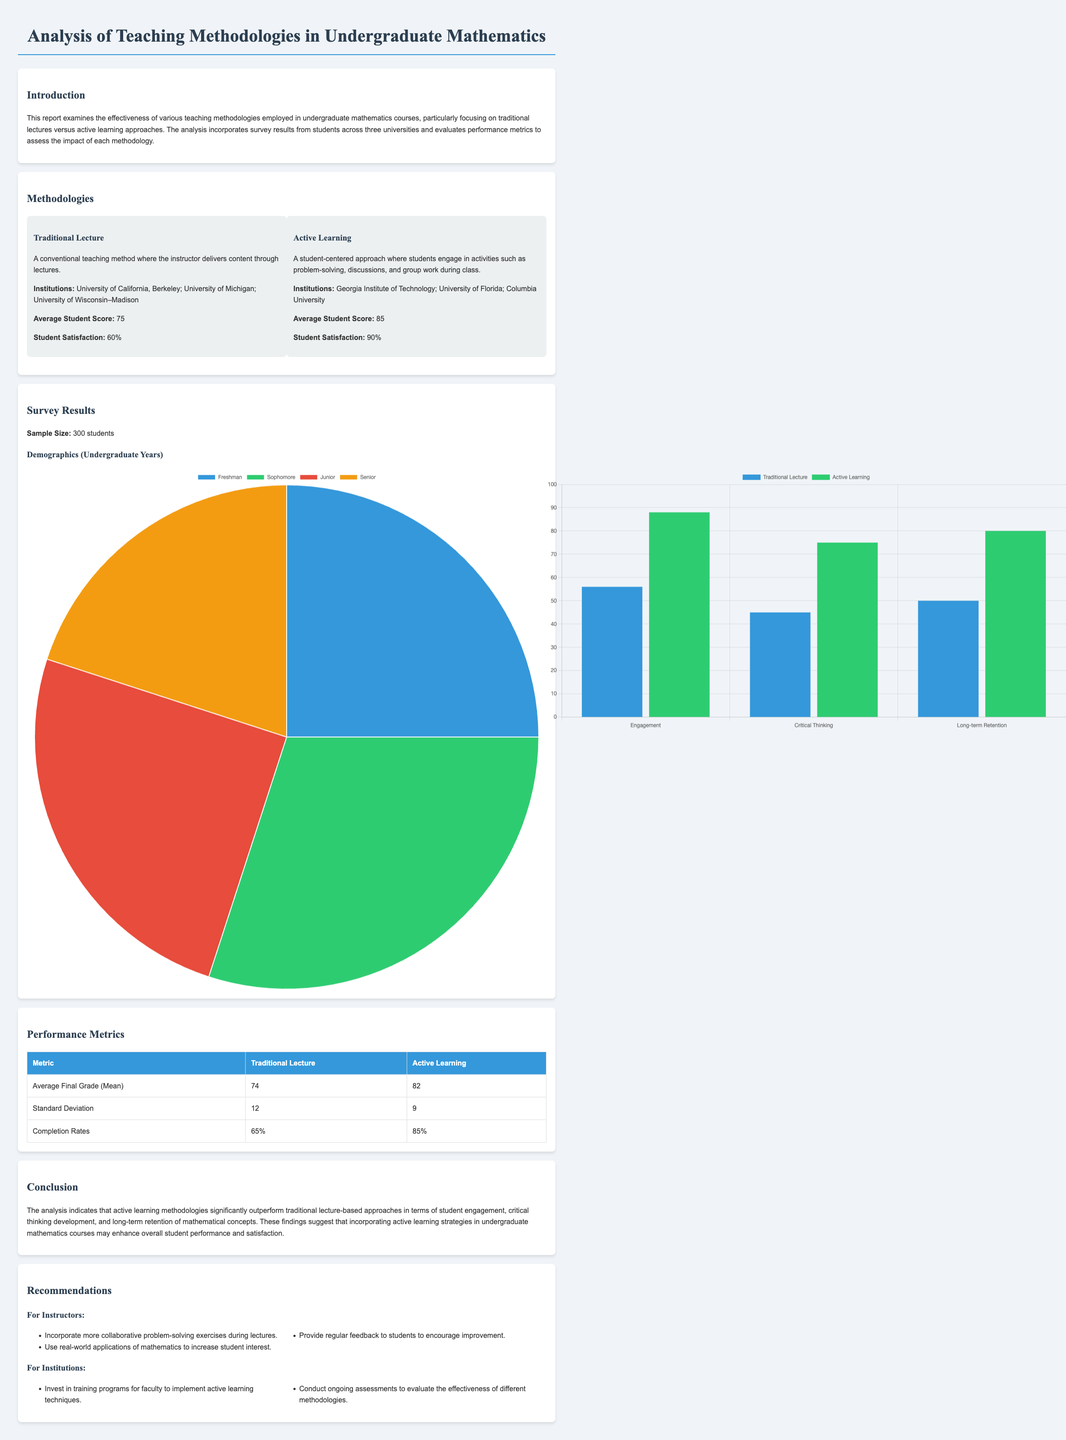What is the average student score for Traditional Lecture? The average student score for Traditional Lecture is explicitly mentioned in the document as 75.
Answer: 75 What is the student satisfaction percentage for Active Learning? The student satisfaction for Active Learning is presented in the document as 90%.
Answer: 90% How many students were surveyed in total? The document states a sample size of 300 students who participated in the survey.
Answer: 300 What was the average final grade for Active Learning? According to the performance metrics table, the average final grade for Active Learning is listed as 82.
Answer: 82 What percentage of students completed the course under Traditional Lecture? The document provides the completion rate for Traditional Lecture as 65%.
Answer: 65% Which teaching methodology had a higher average student score? By comparing the average scores in the document, Active Learning has a higher average student score of 85 compared to Traditional Lecture.
Answer: Active Learning What is one recommendation for instructors mentioned in the report? The report lists several recommendations for instructors, such as incorporating more collaborative problem-solving exercises during lectures.
Answer: Collaborative problem-solving exercises What is the standard deviation for Active Learning? The performance metrics indicate that the standard deviation for Active Learning is 9.
Answer: 9 Which institution is associated with Traditional Lecture methodology? Traditional Lecture methodology is associated with institutions like University of California, Berkeley.
Answer: University of California, Berkeley 